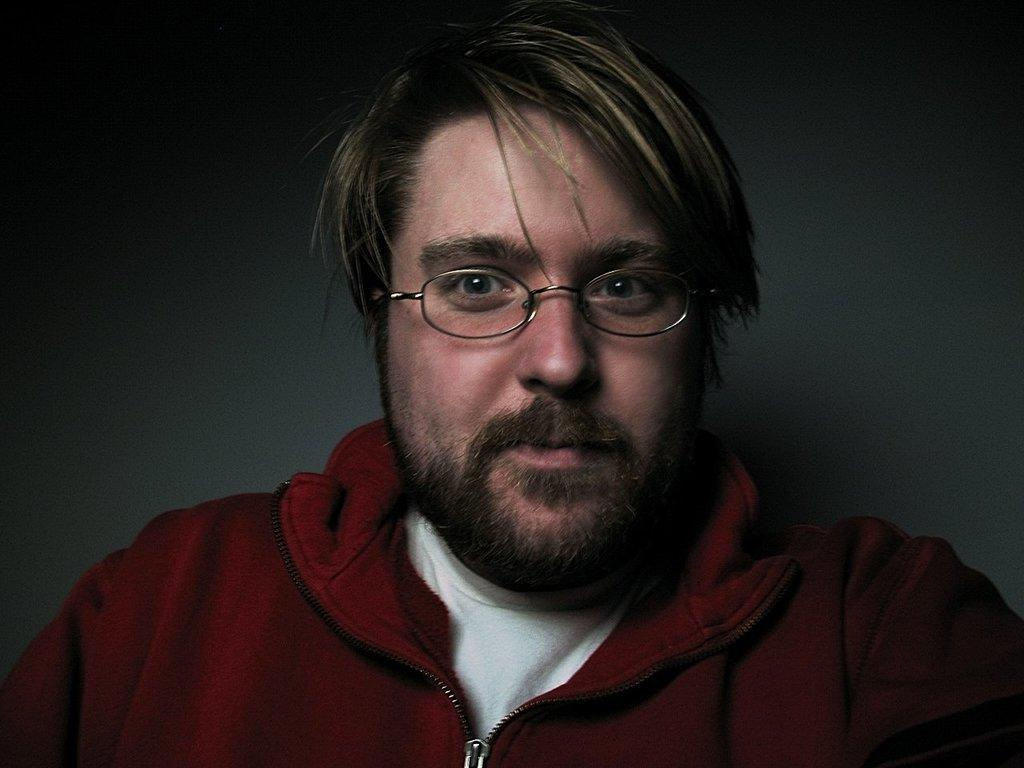Who is present in the image? There is a man in the image. What accessory is the man wearing? The man is wearing glasses (specs). What can be seen in the background of the image? There is a wall in the background of the image. What type of market is depicted in the image? There is no market present in the image; it features a man wearing glasses in front of a wall. What invention is the man holding in the image? The man is not holding any invention in the image; he is simply wearing glasses. 